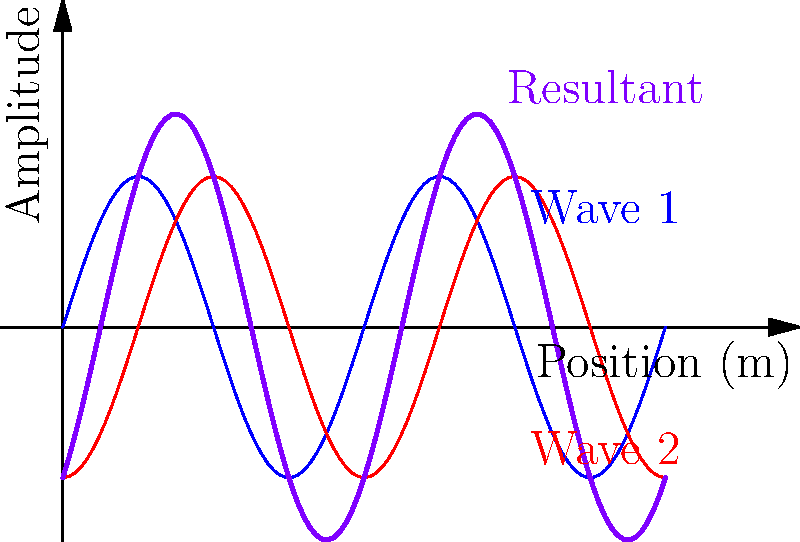In a club setting, two speakers are producing sound waves with the same frequency and amplitude, but slightly out of phase. The graph shows the individual waves (blue and red) and their superposition (purple). At which positions along the x-axis does constructive interference occur, resulting in maximum volume for the clubgoers? To determine the positions of constructive interference, we need to follow these steps:

1. Understand that constructive interference occurs when the two waves are in phase, resulting in maximum amplitude.

2. Observe the purple curve (resultant wave) to identify its peaks, which represent constructive interference.

3. The peaks of the resultant wave occur at regular intervals. In this case, they appear at x = 0, 0.5, 1, 1.5, and 2.

4. These positions correspond to where the blue and red waves align in phase, creating maximum amplitude.

5. The pattern repeats every 0.5 units along the x-axis, which represents half the wavelength of the sound waves.

6. In a real club setting, these positions would correspond to specific locations where the sound is loudest due to the constructive interference of waves from the two speakers.
Answer: x = 0, 0.5, 1, 1.5, 2 (in meters) 